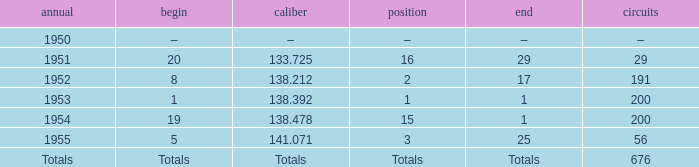What year was the ranking 1? 1953.0. 